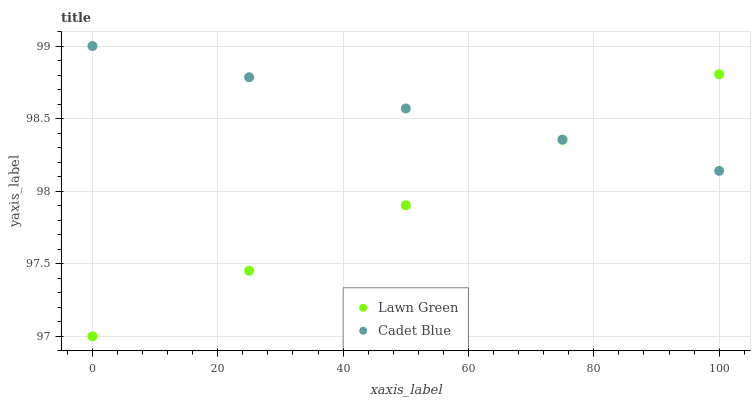Does Lawn Green have the minimum area under the curve?
Answer yes or no. Yes. Does Cadet Blue have the maximum area under the curve?
Answer yes or no. Yes. Does Cadet Blue have the minimum area under the curve?
Answer yes or no. No. Is Cadet Blue the smoothest?
Answer yes or no. Yes. Is Lawn Green the roughest?
Answer yes or no. Yes. Is Cadet Blue the roughest?
Answer yes or no. No. Does Lawn Green have the lowest value?
Answer yes or no. Yes. Does Cadet Blue have the lowest value?
Answer yes or no. No. Does Cadet Blue have the highest value?
Answer yes or no. Yes. Does Cadet Blue intersect Lawn Green?
Answer yes or no. Yes. Is Cadet Blue less than Lawn Green?
Answer yes or no. No. Is Cadet Blue greater than Lawn Green?
Answer yes or no. No. 